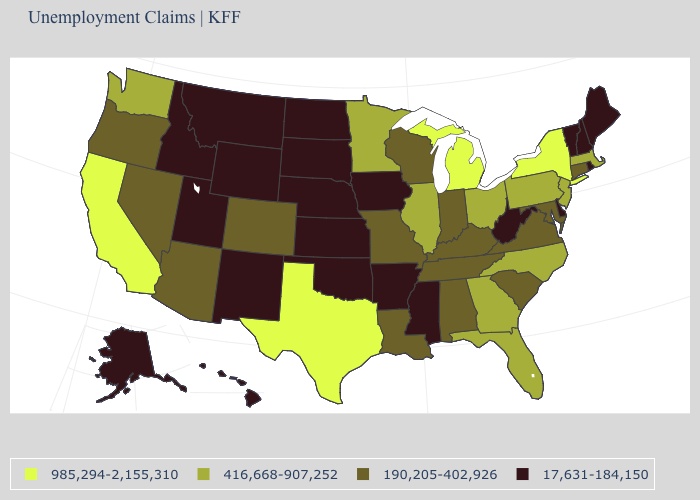Name the states that have a value in the range 190,205-402,926?
Write a very short answer. Alabama, Arizona, Colorado, Connecticut, Indiana, Kentucky, Louisiana, Maryland, Missouri, Nevada, Oregon, South Carolina, Tennessee, Virginia, Wisconsin. Name the states that have a value in the range 190,205-402,926?
Write a very short answer. Alabama, Arizona, Colorado, Connecticut, Indiana, Kentucky, Louisiana, Maryland, Missouri, Nevada, Oregon, South Carolina, Tennessee, Virginia, Wisconsin. How many symbols are there in the legend?
Short answer required. 4. What is the value of Oklahoma?
Answer briefly. 17,631-184,150. Name the states that have a value in the range 985,294-2,155,310?
Write a very short answer. California, Michigan, New York, Texas. Which states have the lowest value in the West?
Concise answer only. Alaska, Hawaii, Idaho, Montana, New Mexico, Utah, Wyoming. Is the legend a continuous bar?
Keep it brief. No. What is the value of Illinois?
Answer briefly. 416,668-907,252. Is the legend a continuous bar?
Quick response, please. No. Is the legend a continuous bar?
Give a very brief answer. No. What is the value of Kansas?
Answer briefly. 17,631-184,150. Does West Virginia have the highest value in the USA?
Short answer required. No. What is the highest value in the USA?
Concise answer only. 985,294-2,155,310. What is the value of Utah?
Keep it brief. 17,631-184,150. Is the legend a continuous bar?
Be succinct. No. 